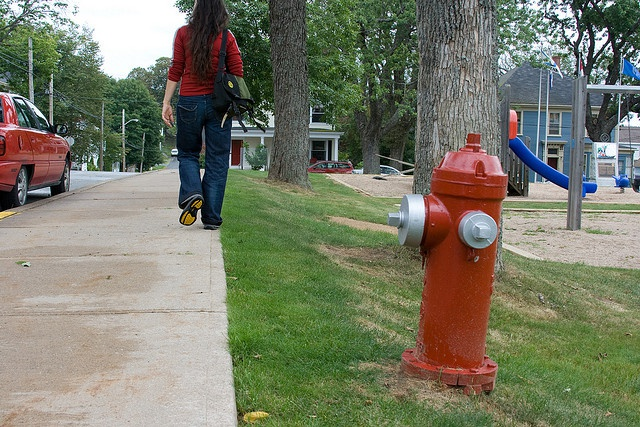Describe the objects in this image and their specific colors. I can see fire hydrant in lightblue, maroon, brown, and gray tones, people in lightblue, black, maroon, navy, and gray tones, car in lightblue, black, brown, and maroon tones, handbag in lightblue, black, gray, maroon, and darkgray tones, and car in lightblue, maroon, gray, brown, and black tones in this image. 